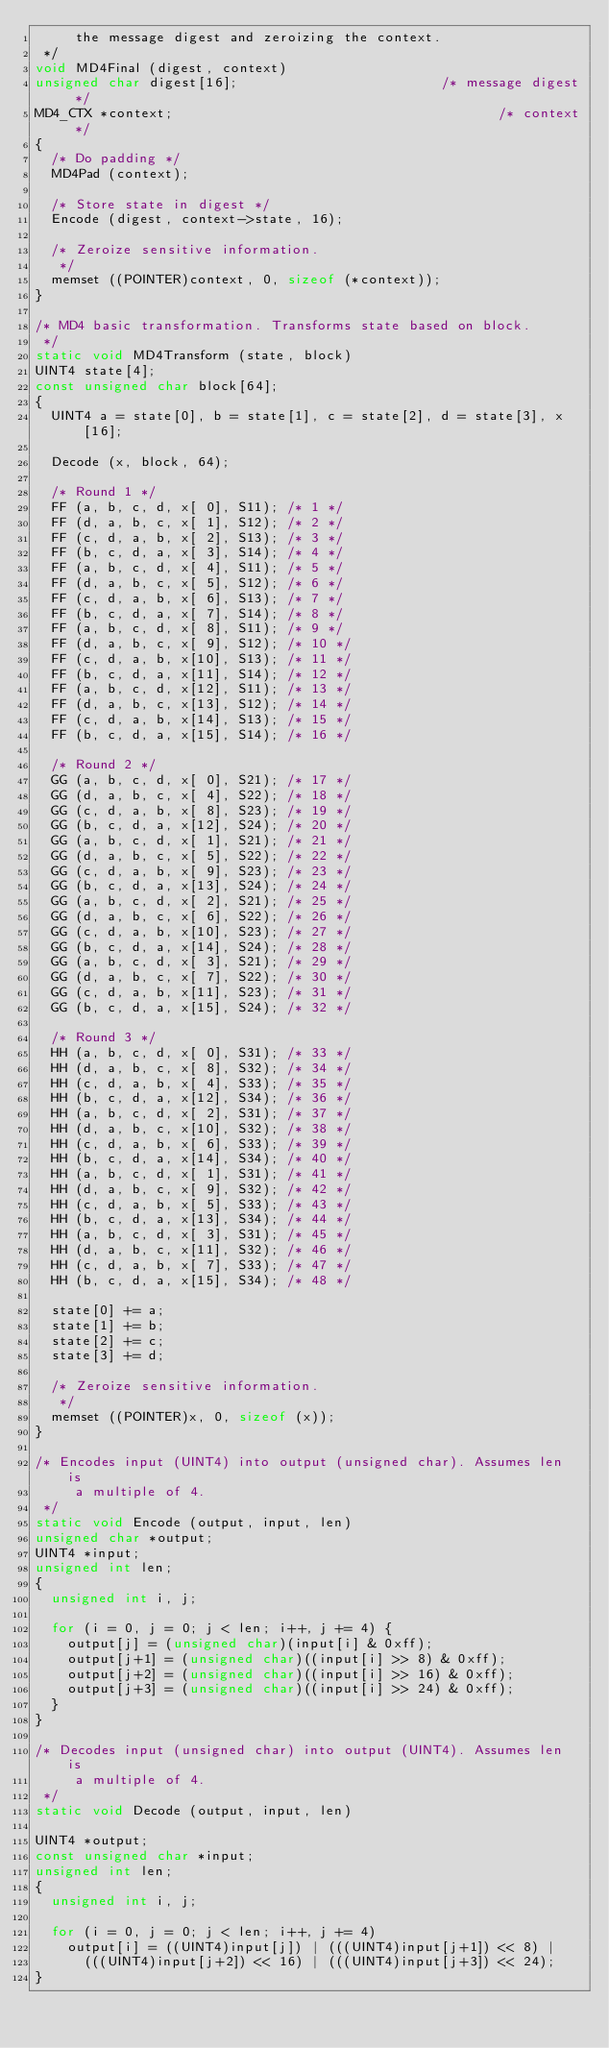Convert code to text. <code><loc_0><loc_0><loc_500><loc_500><_C_>     the message digest and zeroizing the context.
 */
void MD4Final (digest, context)
unsigned char digest[16];                         /* message digest */
MD4_CTX *context;                                        /* context */
{
  /* Do padding */
  MD4Pad (context);

  /* Store state in digest */
  Encode (digest, context->state, 16);

  /* Zeroize sensitive information.
   */
  memset ((POINTER)context, 0, sizeof (*context));
}

/* MD4 basic transformation. Transforms state based on block.
 */
static void MD4Transform (state, block)
UINT4 state[4];
const unsigned char block[64];
{
  UINT4 a = state[0], b = state[1], c = state[2], d = state[3], x[16];

  Decode (x, block, 64);

  /* Round 1 */
  FF (a, b, c, d, x[ 0], S11); /* 1 */
  FF (d, a, b, c, x[ 1], S12); /* 2 */
  FF (c, d, a, b, x[ 2], S13); /* 3 */
  FF (b, c, d, a, x[ 3], S14); /* 4 */
  FF (a, b, c, d, x[ 4], S11); /* 5 */
  FF (d, a, b, c, x[ 5], S12); /* 6 */
  FF (c, d, a, b, x[ 6], S13); /* 7 */
  FF (b, c, d, a, x[ 7], S14); /* 8 */
  FF (a, b, c, d, x[ 8], S11); /* 9 */
  FF (d, a, b, c, x[ 9], S12); /* 10 */
  FF (c, d, a, b, x[10], S13); /* 11 */
  FF (b, c, d, a, x[11], S14); /* 12 */
  FF (a, b, c, d, x[12], S11); /* 13 */
  FF (d, a, b, c, x[13], S12); /* 14 */
  FF (c, d, a, b, x[14], S13); /* 15 */
  FF (b, c, d, a, x[15], S14); /* 16 */

  /* Round 2 */
  GG (a, b, c, d, x[ 0], S21); /* 17 */
  GG (d, a, b, c, x[ 4], S22); /* 18 */
  GG (c, d, a, b, x[ 8], S23); /* 19 */
  GG (b, c, d, a, x[12], S24); /* 20 */
  GG (a, b, c, d, x[ 1], S21); /* 21 */
  GG (d, a, b, c, x[ 5], S22); /* 22 */
  GG (c, d, a, b, x[ 9], S23); /* 23 */
  GG (b, c, d, a, x[13], S24); /* 24 */
  GG (a, b, c, d, x[ 2], S21); /* 25 */
  GG (d, a, b, c, x[ 6], S22); /* 26 */
  GG (c, d, a, b, x[10], S23); /* 27 */
  GG (b, c, d, a, x[14], S24); /* 28 */
  GG (a, b, c, d, x[ 3], S21); /* 29 */
  GG (d, a, b, c, x[ 7], S22); /* 30 */
  GG (c, d, a, b, x[11], S23); /* 31 */
  GG (b, c, d, a, x[15], S24); /* 32 */

  /* Round 3 */
  HH (a, b, c, d, x[ 0], S31); /* 33 */
  HH (d, a, b, c, x[ 8], S32); /* 34 */
  HH (c, d, a, b, x[ 4], S33); /* 35 */
  HH (b, c, d, a, x[12], S34); /* 36 */
  HH (a, b, c, d, x[ 2], S31); /* 37 */
  HH (d, a, b, c, x[10], S32); /* 38 */
  HH (c, d, a, b, x[ 6], S33); /* 39 */
  HH (b, c, d, a, x[14], S34); /* 40 */
  HH (a, b, c, d, x[ 1], S31); /* 41 */
  HH (d, a, b, c, x[ 9], S32); /* 42 */
  HH (c, d, a, b, x[ 5], S33); /* 43 */
  HH (b, c, d, a, x[13], S34); /* 44 */
  HH (a, b, c, d, x[ 3], S31); /* 45 */
  HH (d, a, b, c, x[11], S32); /* 46 */
  HH (c, d, a, b, x[ 7], S33); /* 47 */
  HH (b, c, d, a, x[15], S34); /* 48 */

  state[0] += a;
  state[1] += b;
  state[2] += c;
  state[3] += d;

  /* Zeroize sensitive information.
   */
  memset ((POINTER)x, 0, sizeof (x));
}

/* Encodes input (UINT4) into output (unsigned char). Assumes len is
     a multiple of 4.
 */
static void Encode (output, input, len)
unsigned char *output;
UINT4 *input;
unsigned int len;
{
  unsigned int i, j;

  for (i = 0, j = 0; j < len; i++, j += 4) {
    output[j] = (unsigned char)(input[i] & 0xff);
    output[j+1] = (unsigned char)((input[i] >> 8) & 0xff);
    output[j+2] = (unsigned char)((input[i] >> 16) & 0xff);
    output[j+3] = (unsigned char)((input[i] >> 24) & 0xff);
  }
}

/* Decodes input (unsigned char) into output (UINT4). Assumes len is
     a multiple of 4.
 */
static void Decode (output, input, len)

UINT4 *output;
const unsigned char *input;
unsigned int len;
{
  unsigned int i, j;

  for (i = 0, j = 0; j < len; i++, j += 4)
    output[i] = ((UINT4)input[j]) | (((UINT4)input[j+1]) << 8) |
      (((UINT4)input[j+2]) << 16) | (((UINT4)input[j+3]) << 24);
}
</code> 